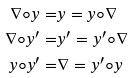Convert formula to latex. <formula><loc_0><loc_0><loc_500><loc_500>\nabla \circ y = & y = y \circ \nabla \\ \nabla \circ y ^ { \prime } = & y ^ { \prime } = y ^ { \prime } \circ \nabla \\ y \circ y ^ { \prime } = & \nabla = y ^ { \prime } \circ y</formula> 